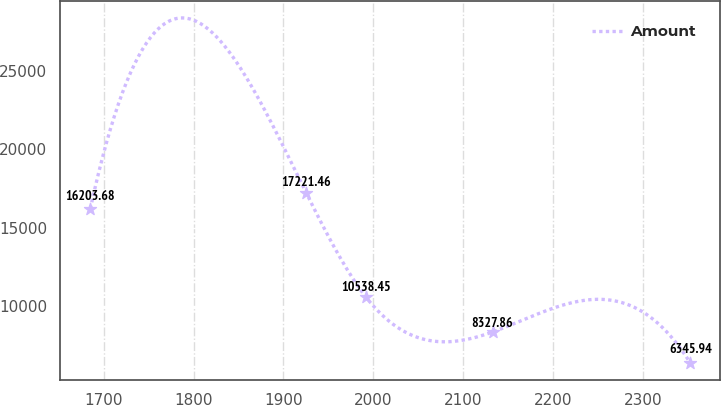<chart> <loc_0><loc_0><loc_500><loc_500><line_chart><ecel><fcel>Amount<nl><fcel>1685.16<fcel>16203.7<nl><fcel>1925.39<fcel>17221.5<nl><fcel>1992.15<fcel>10538.5<nl><fcel>2132.78<fcel>8327.86<nl><fcel>2352.78<fcel>6345.94<nl></chart> 